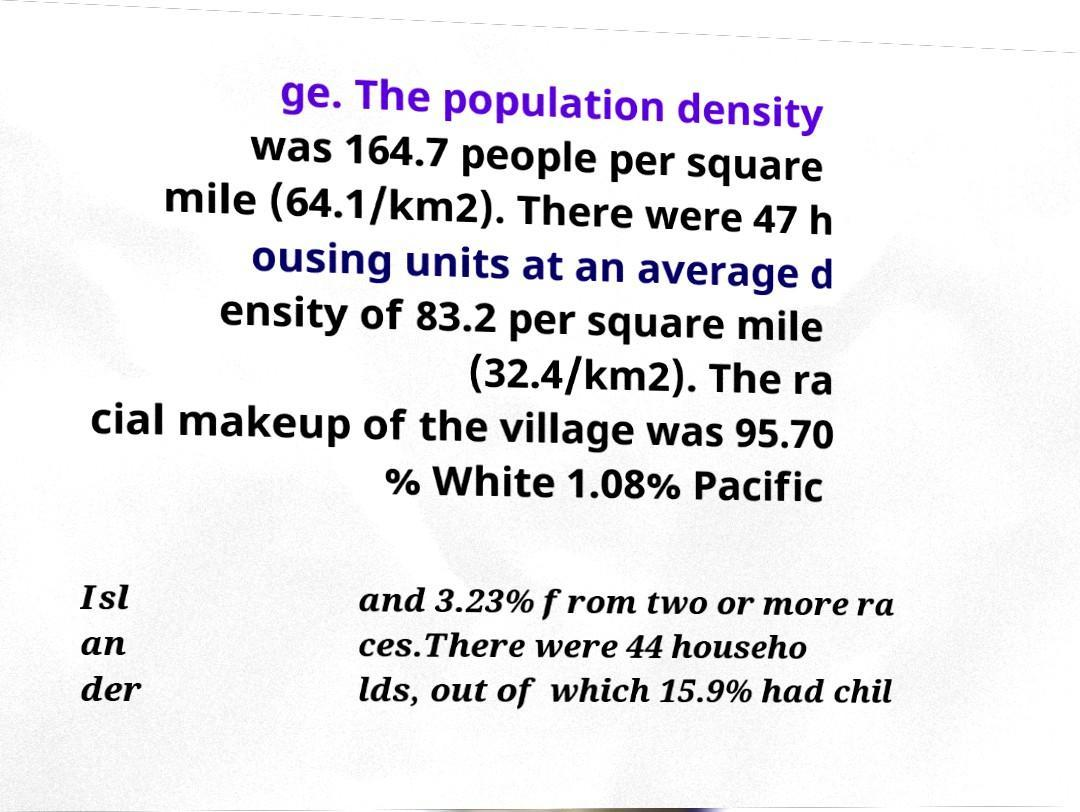Could you assist in decoding the text presented in this image and type it out clearly? ge. The population density was 164.7 people per square mile (64.1/km2). There were 47 h ousing units at an average d ensity of 83.2 per square mile (32.4/km2). The ra cial makeup of the village was 95.70 % White 1.08% Pacific Isl an der and 3.23% from two or more ra ces.There were 44 househo lds, out of which 15.9% had chil 